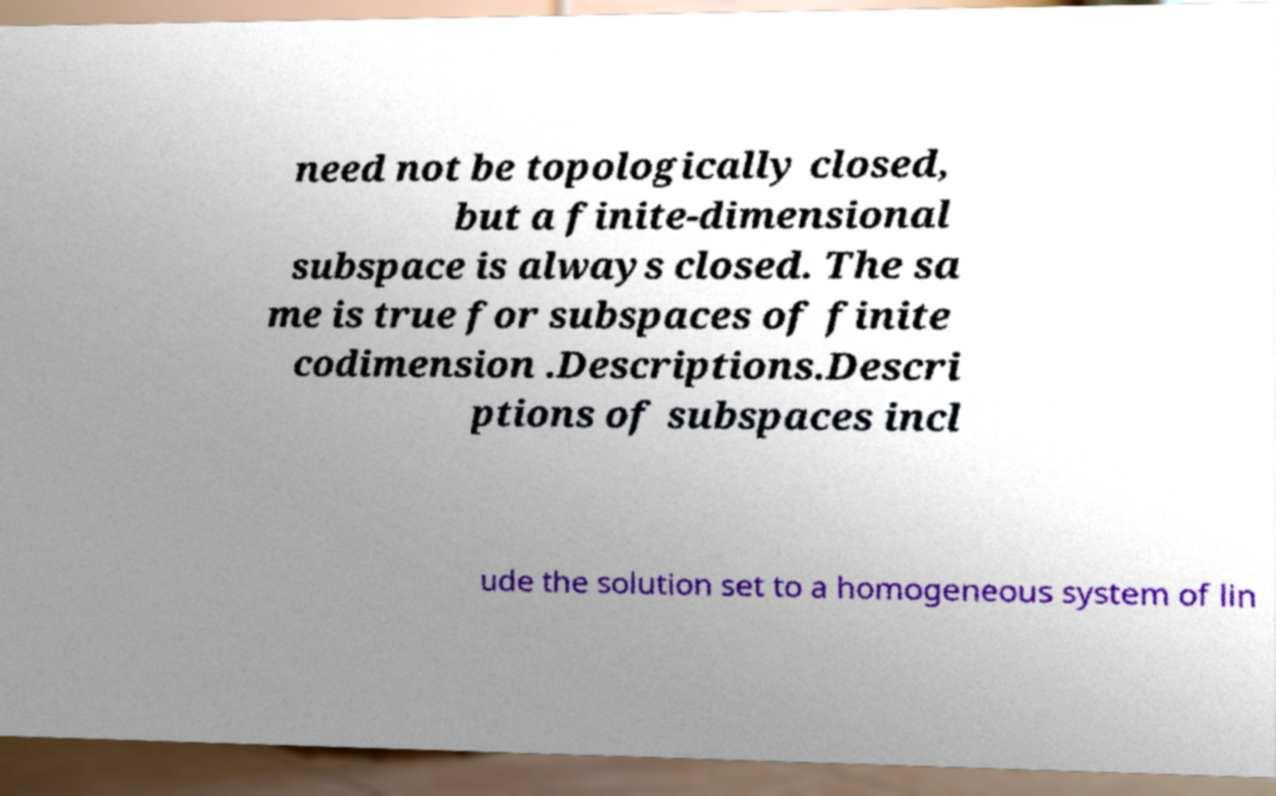I need the written content from this picture converted into text. Can you do that? need not be topologically closed, but a finite-dimensional subspace is always closed. The sa me is true for subspaces of finite codimension .Descriptions.Descri ptions of subspaces incl ude the solution set to a homogeneous system of lin 